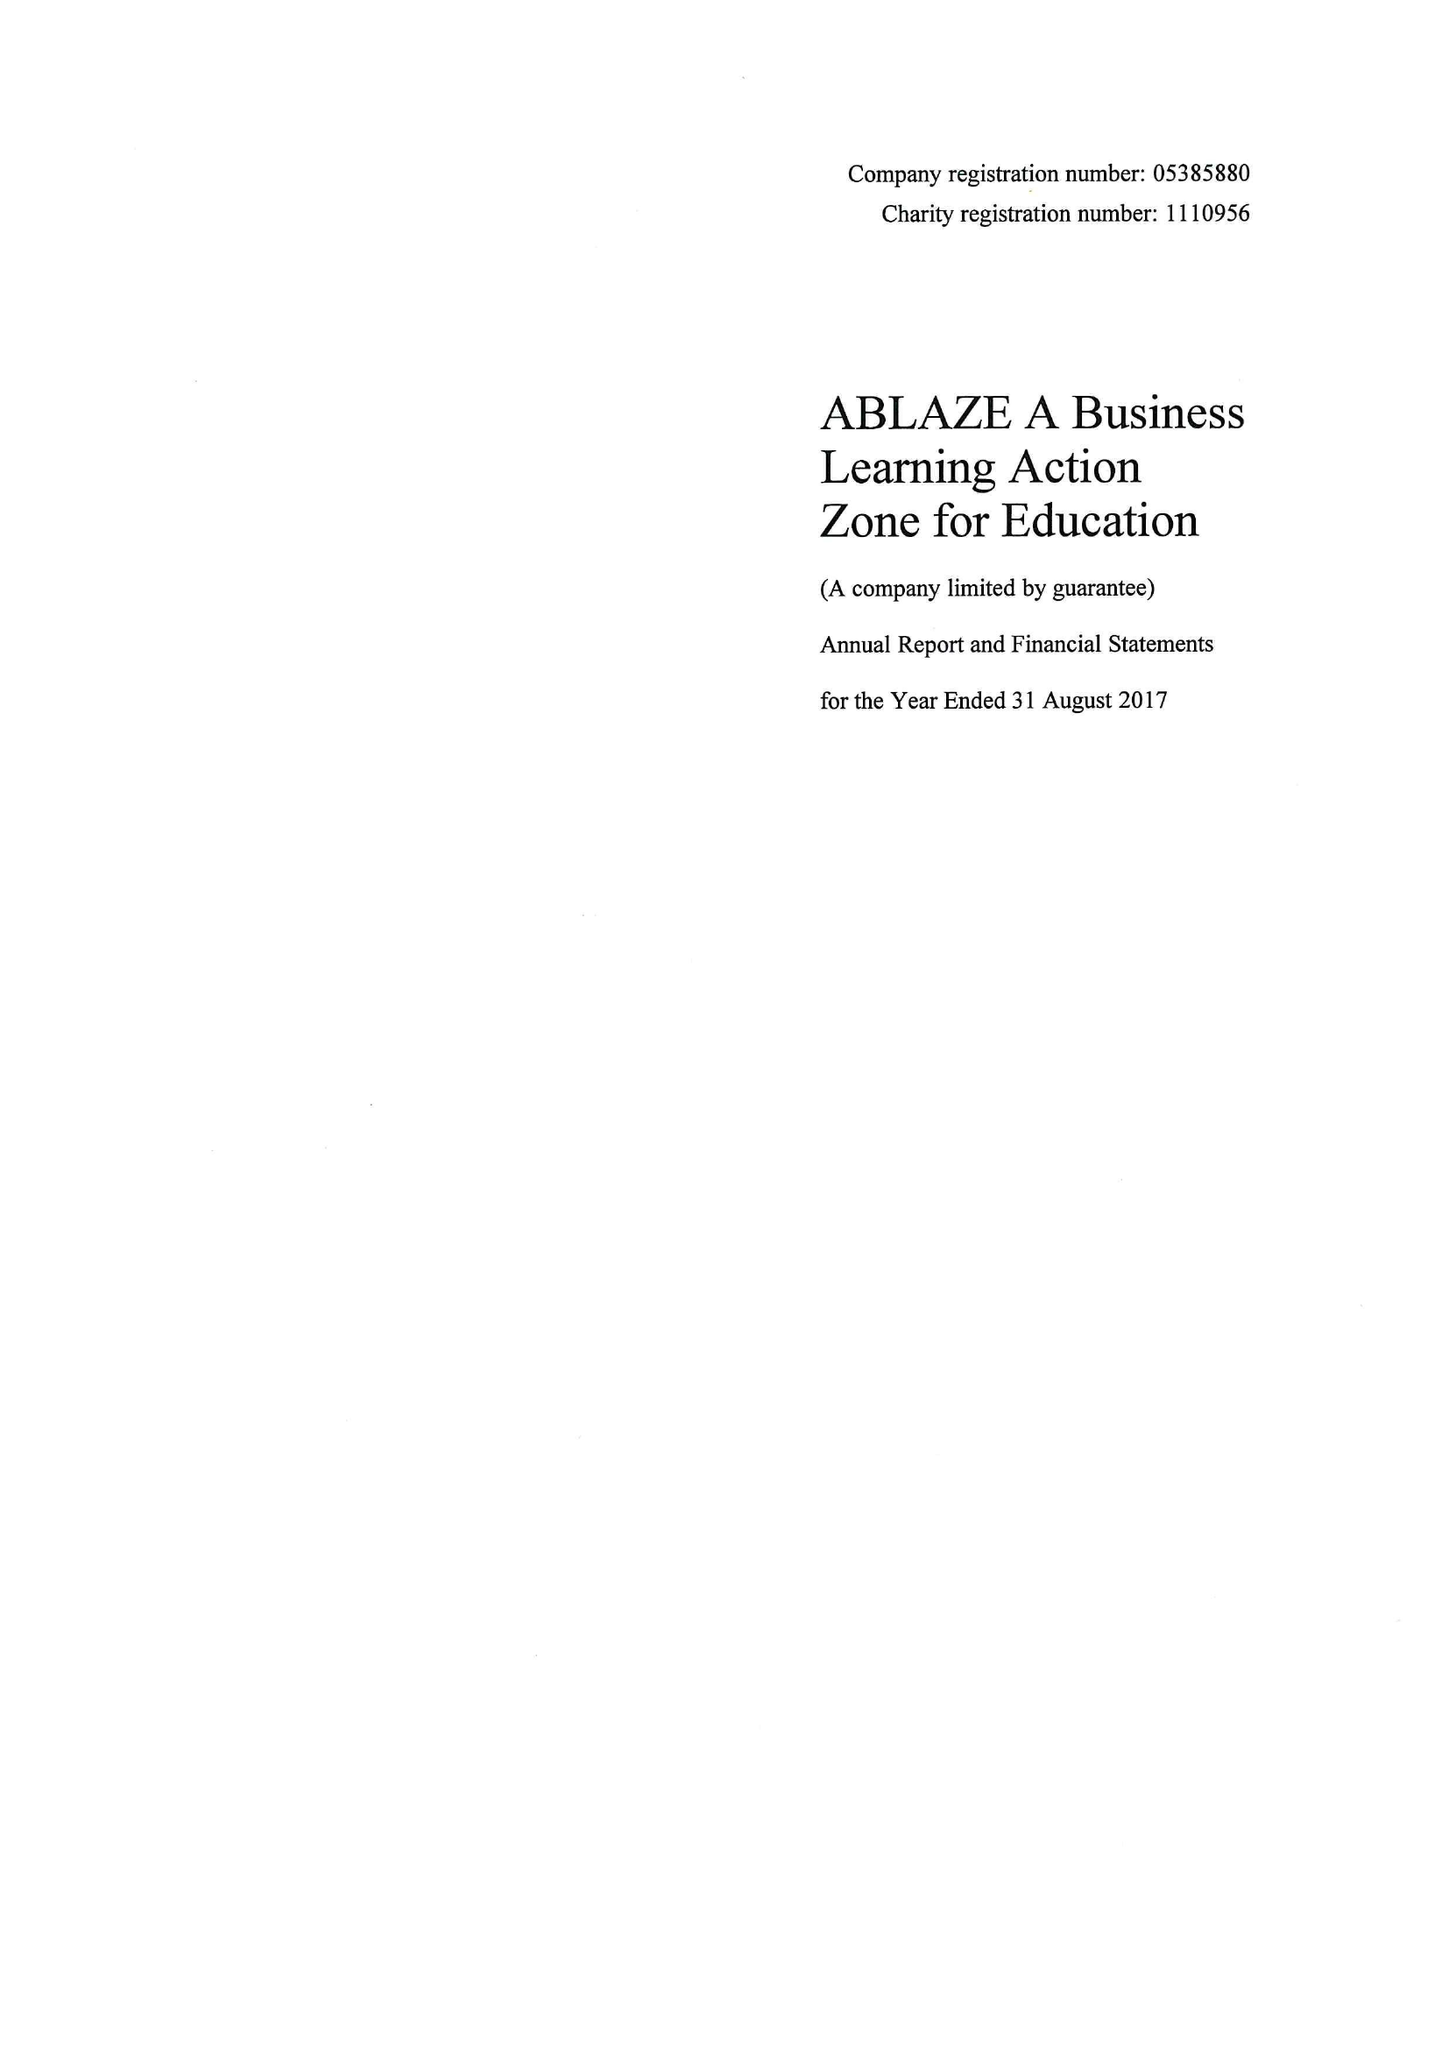What is the value for the address__street_line?
Answer the question using a single word or phrase. REDCLIFFE WAY 